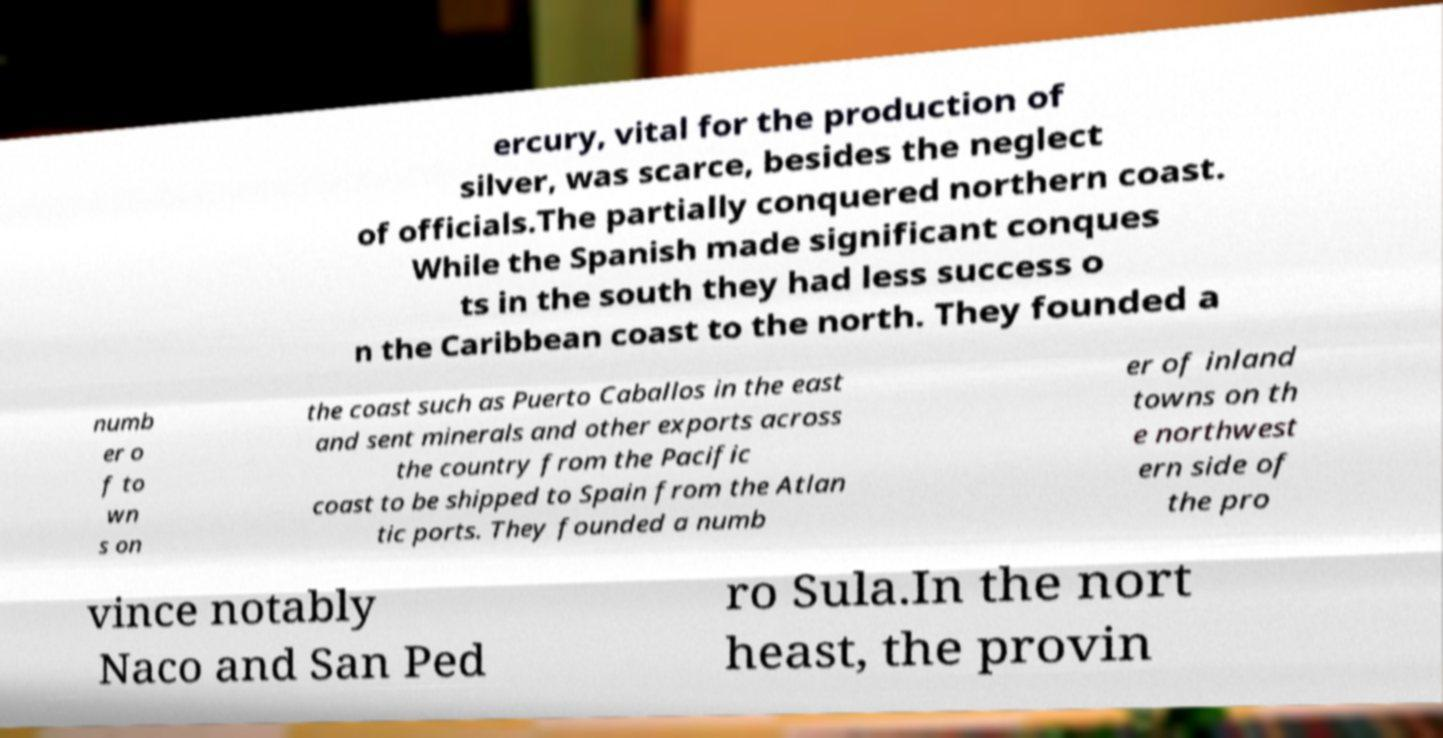I need the written content from this picture converted into text. Can you do that? ercury, vital for the production of silver, was scarce, besides the neglect of officials.The partially conquered northern coast. While the Spanish made significant conques ts in the south they had less success o n the Caribbean coast to the north. They founded a numb er o f to wn s on the coast such as Puerto Caballos in the east and sent minerals and other exports across the country from the Pacific coast to be shipped to Spain from the Atlan tic ports. They founded a numb er of inland towns on th e northwest ern side of the pro vince notably Naco and San Ped ro Sula.In the nort heast, the provin 